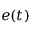<formula> <loc_0><loc_0><loc_500><loc_500>e ( t )</formula> 